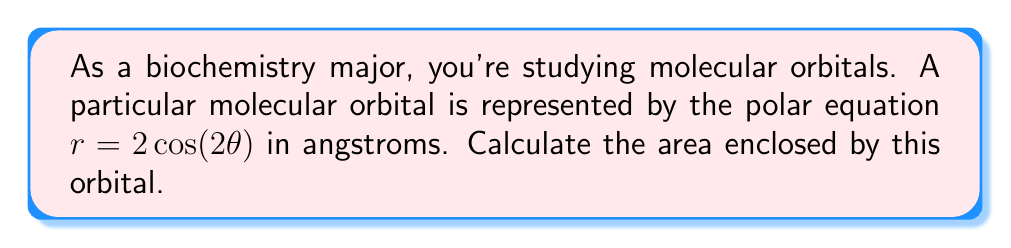What is the answer to this math problem? To calculate the area enclosed by the polar curve $r = 2\cos(2\theta)$, we'll follow these steps:

1) The general formula for the area enclosed by a polar curve is:

   $$A = \frac{1}{2}\int_{0}^{2\pi} r^2 d\theta$$

2) Substitute our equation $r = 2\cos(2\theta)$ into this formula:

   $$A = \frac{1}{2}\int_{0}^{2\pi} (2\cos(2\theta))^2 d\theta$$

3) Simplify the integrand:

   $$A = \frac{1}{2}\int_{0}^{2\pi} 4\cos^2(2\theta) d\theta$$

4) Use the trigonometric identity $\cos^2(x) = \frac{1}{2}(1 + \cos(2x))$:

   $$A = \frac{1}{2}\int_{0}^{2\pi} 4 \cdot \frac{1}{2}(1 + \cos(4\theta)) d\theta$$
   $$A = \int_{0}^{2\pi} (1 + \cos(4\theta)) d\theta$$

5) Integrate:

   $$A = [\theta + \frac{1}{4}\sin(4\theta)]_{0}^{2\pi}$$

6) Evaluate the integral:

   $$A = (2\pi + 0) - (0 + 0) = 2\pi$$

7) The result is in square angstroms (Å²). To convert to square nanometers (nm²), divide by 100:

   $$A = \frac{2\pi}{100} \approx 0.0628 \text{ nm}^2$$
Answer: The area enclosed by the molecular orbital is $2\pi$ Å² or approximately $0.0628$ nm². 